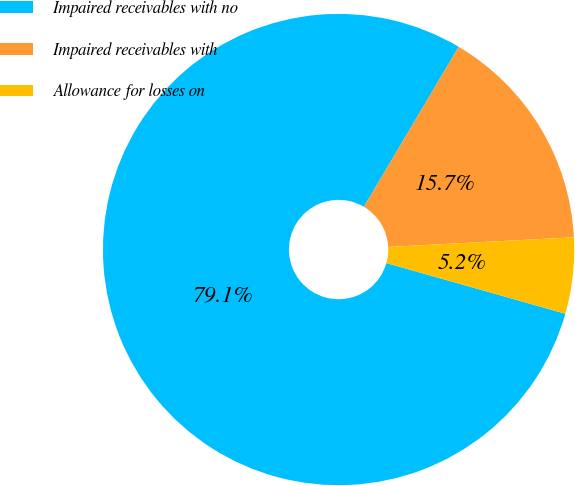Convert chart to OTSL. <chart><loc_0><loc_0><loc_500><loc_500><pie_chart><fcel>Impaired receivables with no<fcel>Impaired receivables with<fcel>Allowance for losses on<nl><fcel>79.12%<fcel>15.66%<fcel>5.22%<nl></chart> 